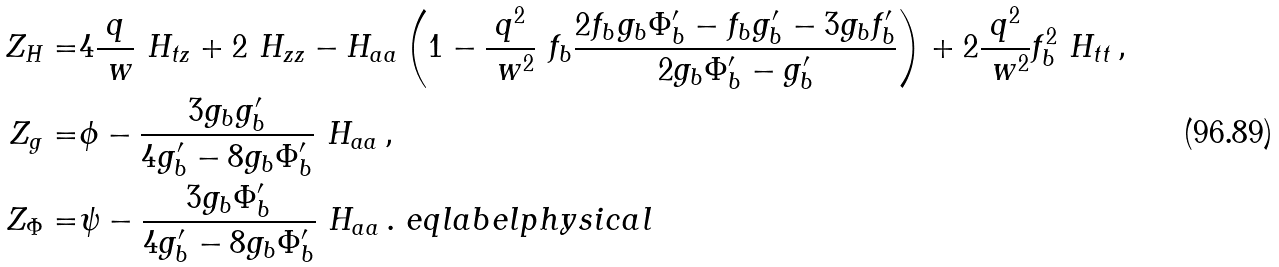Convert formula to latex. <formula><loc_0><loc_0><loc_500><loc_500>Z _ { H } = & 4 \frac { q } { \ w } \ H _ { t z } + 2 \ H _ { z z } - H _ { a a } \left ( 1 - \frac { q ^ { 2 } } { \ w ^ { 2 } } \ f _ { b } \frac { 2 f _ { b } g _ { b } \Phi _ { b } ^ { \prime } - f _ { b } g _ { b } ^ { \prime } - 3 g _ { b } f _ { b } ^ { \prime } } { 2 g _ { b } \Phi _ { b } ^ { \prime } - g _ { b } ^ { \prime } } \right ) + 2 \frac { q ^ { 2 } } { \ w ^ { 2 } } f _ { b } ^ { 2 } \ H _ { t t } \, , \\ Z _ { g } = & \phi - \frac { 3 g _ { b } g _ { b } ^ { \prime } } { 4 g _ { b } ^ { \prime } - 8 g _ { b } \Phi _ { b } ^ { \prime } } \ H _ { a a } \, , \\ Z _ { \Phi } = & \psi - \frac { 3 g _ { b } \Phi _ { b } ^ { \prime } } { 4 g _ { b } ^ { \prime } - 8 g _ { b } \Phi _ { b } ^ { \prime } } \ H _ { a a } \, . \ e q l a b e l { p h y s i c a l }</formula> 